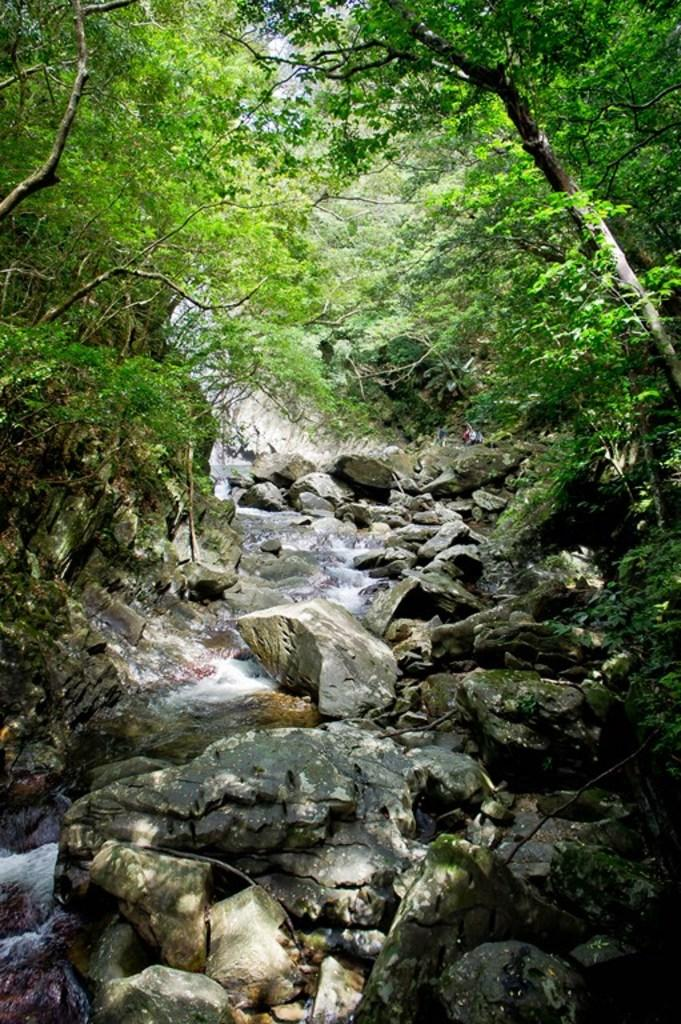What is the primary feature of the image? There are many stones in the image. What can be seen at the top of the image? There are trees, plants, and grass at the top of the image. Is there any indication of water in the image? Yes, there is water flow visible in the bottom left corner of the image. What type of music can be heard playing in the background of the image? There is no music present in the image, as it is a still photograph of stones, trees, plants, grass, and water flow. 